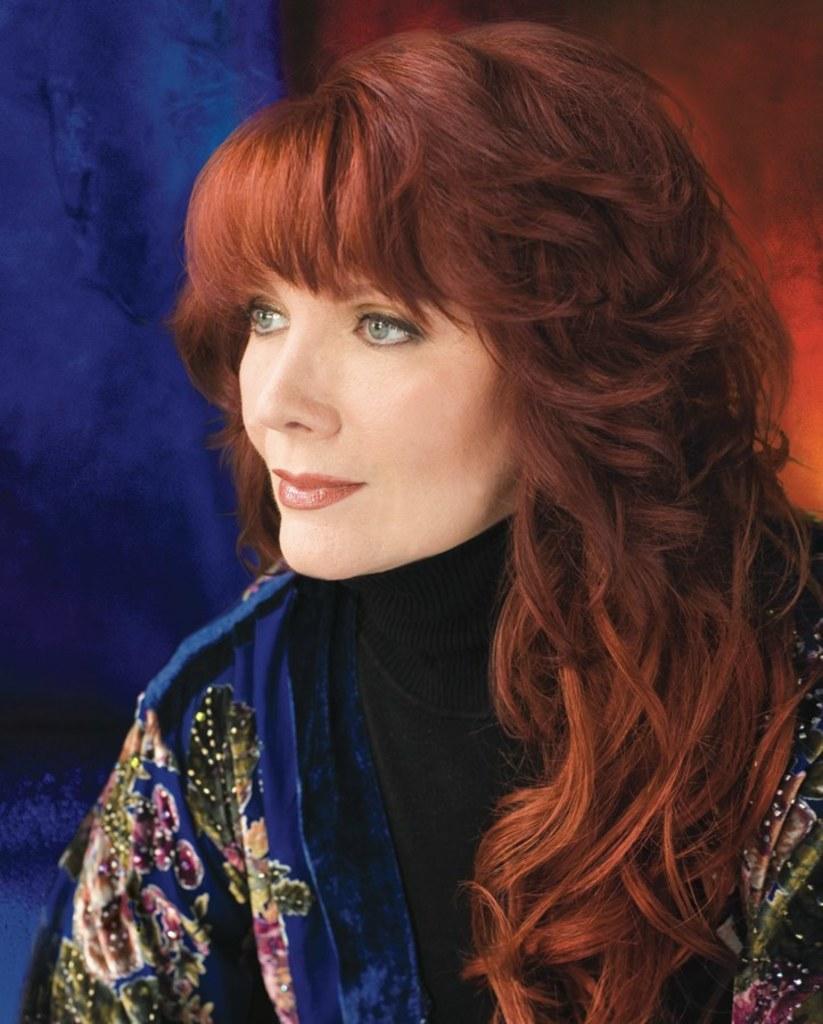How would you summarize this image in a sentence or two? In the center of the image we can see a lady and wearing blue dress. 